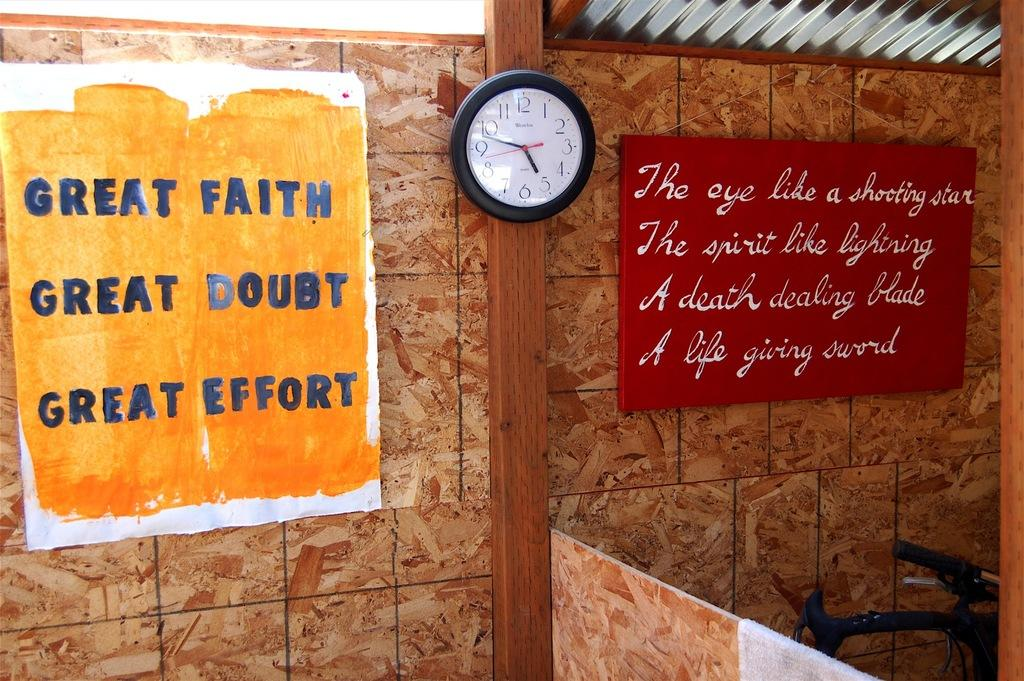Provide a one-sentence caption for the provided image. A clock is between two signs that have motivational sayings on them. 